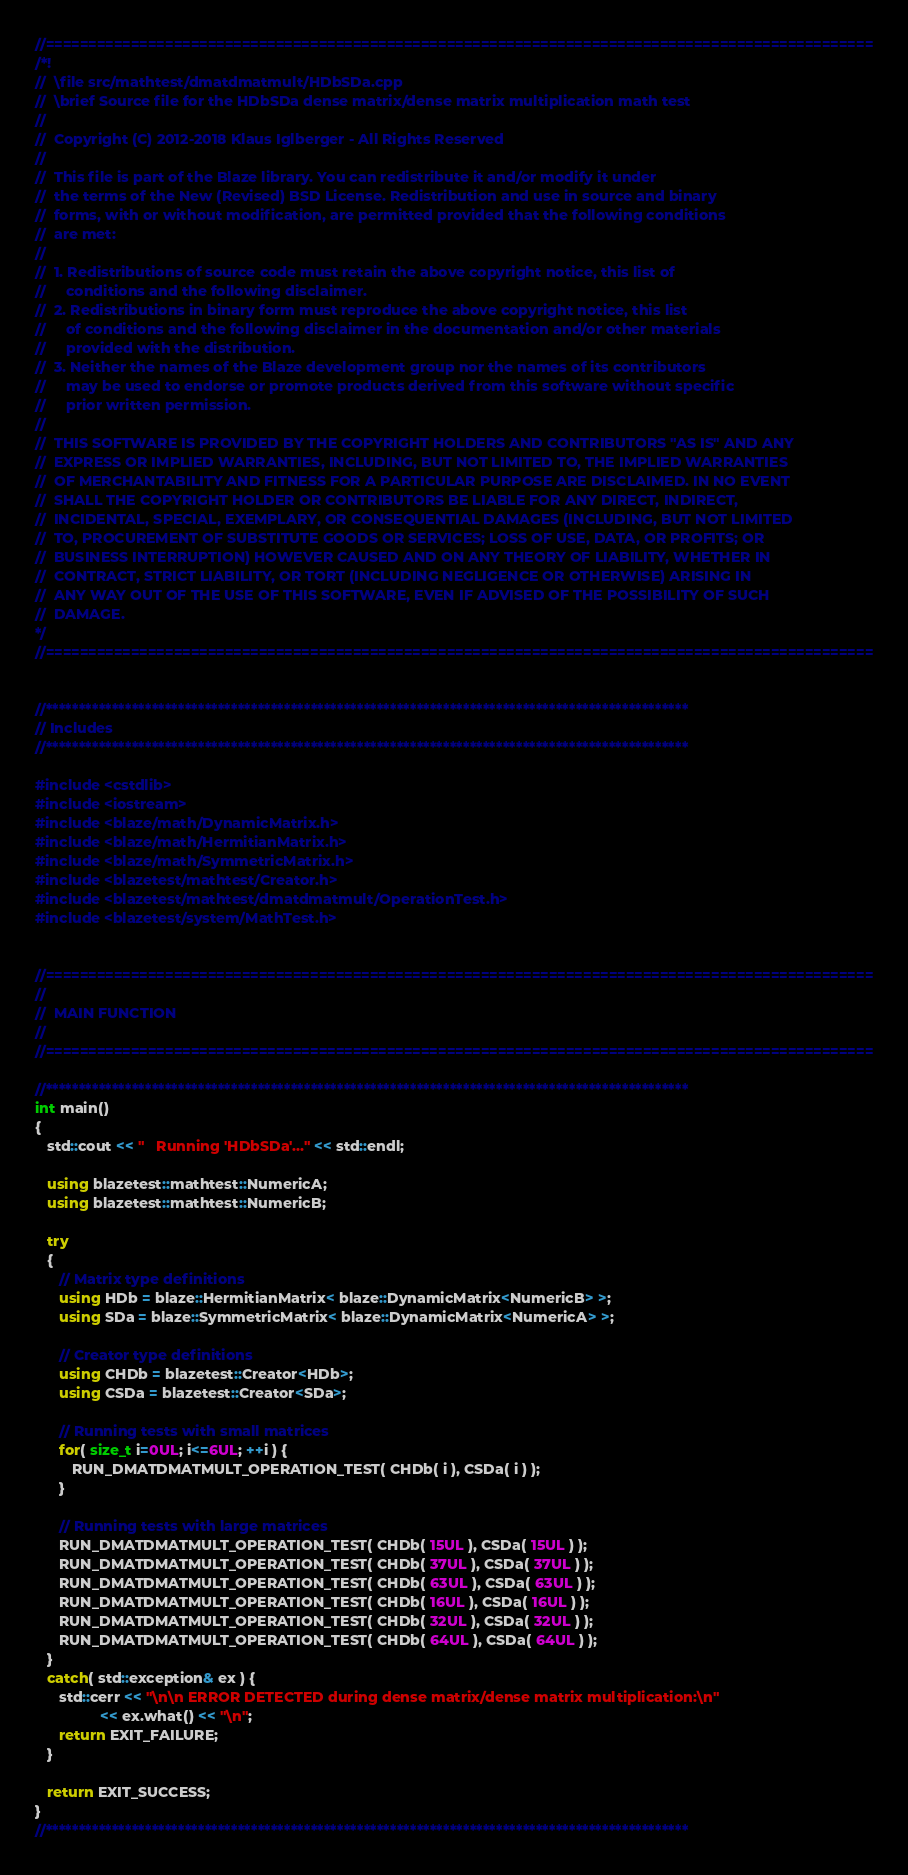<code> <loc_0><loc_0><loc_500><loc_500><_C++_>//=================================================================================================
/*!
//  \file src/mathtest/dmatdmatmult/HDbSDa.cpp
//  \brief Source file for the HDbSDa dense matrix/dense matrix multiplication math test
//
//  Copyright (C) 2012-2018 Klaus Iglberger - All Rights Reserved
//
//  This file is part of the Blaze library. You can redistribute it and/or modify it under
//  the terms of the New (Revised) BSD License. Redistribution and use in source and binary
//  forms, with or without modification, are permitted provided that the following conditions
//  are met:
//
//  1. Redistributions of source code must retain the above copyright notice, this list of
//     conditions and the following disclaimer.
//  2. Redistributions in binary form must reproduce the above copyright notice, this list
//     of conditions and the following disclaimer in the documentation and/or other materials
//     provided with the distribution.
//  3. Neither the names of the Blaze development group nor the names of its contributors
//     may be used to endorse or promote products derived from this software without specific
//     prior written permission.
//
//  THIS SOFTWARE IS PROVIDED BY THE COPYRIGHT HOLDERS AND CONTRIBUTORS "AS IS" AND ANY
//  EXPRESS OR IMPLIED WARRANTIES, INCLUDING, BUT NOT LIMITED TO, THE IMPLIED WARRANTIES
//  OF MERCHANTABILITY AND FITNESS FOR A PARTICULAR PURPOSE ARE DISCLAIMED. IN NO EVENT
//  SHALL THE COPYRIGHT HOLDER OR CONTRIBUTORS BE LIABLE FOR ANY DIRECT, INDIRECT,
//  INCIDENTAL, SPECIAL, EXEMPLARY, OR CONSEQUENTIAL DAMAGES (INCLUDING, BUT NOT LIMITED
//  TO, PROCUREMENT OF SUBSTITUTE GOODS OR SERVICES; LOSS OF USE, DATA, OR PROFITS; OR
//  BUSINESS INTERRUPTION) HOWEVER CAUSED AND ON ANY THEORY OF LIABILITY, WHETHER IN
//  CONTRACT, STRICT LIABILITY, OR TORT (INCLUDING NEGLIGENCE OR OTHERWISE) ARISING IN
//  ANY WAY OUT OF THE USE OF THIS SOFTWARE, EVEN IF ADVISED OF THE POSSIBILITY OF SUCH
//  DAMAGE.
*/
//=================================================================================================


//*************************************************************************************************
// Includes
//*************************************************************************************************

#include <cstdlib>
#include <iostream>
#include <blaze/math/DynamicMatrix.h>
#include <blaze/math/HermitianMatrix.h>
#include <blaze/math/SymmetricMatrix.h>
#include <blazetest/mathtest/Creator.h>
#include <blazetest/mathtest/dmatdmatmult/OperationTest.h>
#include <blazetest/system/MathTest.h>


//=================================================================================================
//
//  MAIN FUNCTION
//
//=================================================================================================

//*************************************************************************************************
int main()
{
   std::cout << "   Running 'HDbSDa'..." << std::endl;

   using blazetest::mathtest::NumericA;
   using blazetest::mathtest::NumericB;

   try
   {
      // Matrix type definitions
      using HDb = blaze::HermitianMatrix< blaze::DynamicMatrix<NumericB> >;
      using SDa = blaze::SymmetricMatrix< blaze::DynamicMatrix<NumericA> >;

      // Creator type definitions
      using CHDb = blazetest::Creator<HDb>;
      using CSDa = blazetest::Creator<SDa>;

      // Running tests with small matrices
      for( size_t i=0UL; i<=6UL; ++i ) {
         RUN_DMATDMATMULT_OPERATION_TEST( CHDb( i ), CSDa( i ) );
      }

      // Running tests with large matrices
      RUN_DMATDMATMULT_OPERATION_TEST( CHDb( 15UL ), CSDa( 15UL ) );
      RUN_DMATDMATMULT_OPERATION_TEST( CHDb( 37UL ), CSDa( 37UL ) );
      RUN_DMATDMATMULT_OPERATION_TEST( CHDb( 63UL ), CSDa( 63UL ) );
      RUN_DMATDMATMULT_OPERATION_TEST( CHDb( 16UL ), CSDa( 16UL ) );
      RUN_DMATDMATMULT_OPERATION_TEST( CHDb( 32UL ), CSDa( 32UL ) );
      RUN_DMATDMATMULT_OPERATION_TEST( CHDb( 64UL ), CSDa( 64UL ) );
   }
   catch( std::exception& ex ) {
      std::cerr << "\n\n ERROR DETECTED during dense matrix/dense matrix multiplication:\n"
                << ex.what() << "\n";
      return EXIT_FAILURE;
   }

   return EXIT_SUCCESS;
}
//*************************************************************************************************
</code> 